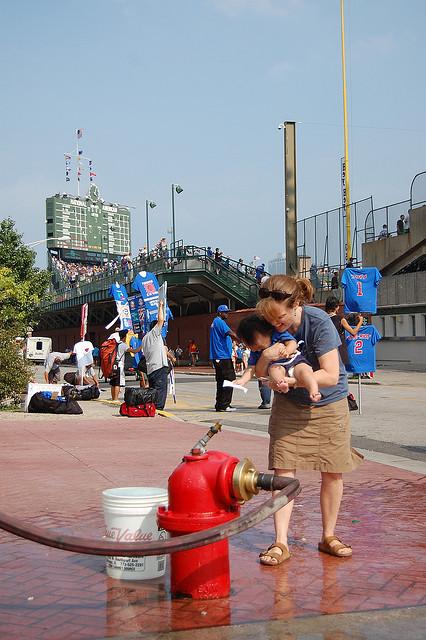Is the lady holding a baby?
Answer briefly. Yes. Why is the lady wearing those shoes?
Be succinct. Water. Are there any people in this photo?
Write a very short answer. Yes. What ballpark is this?
Write a very short answer. Wrigley field. 